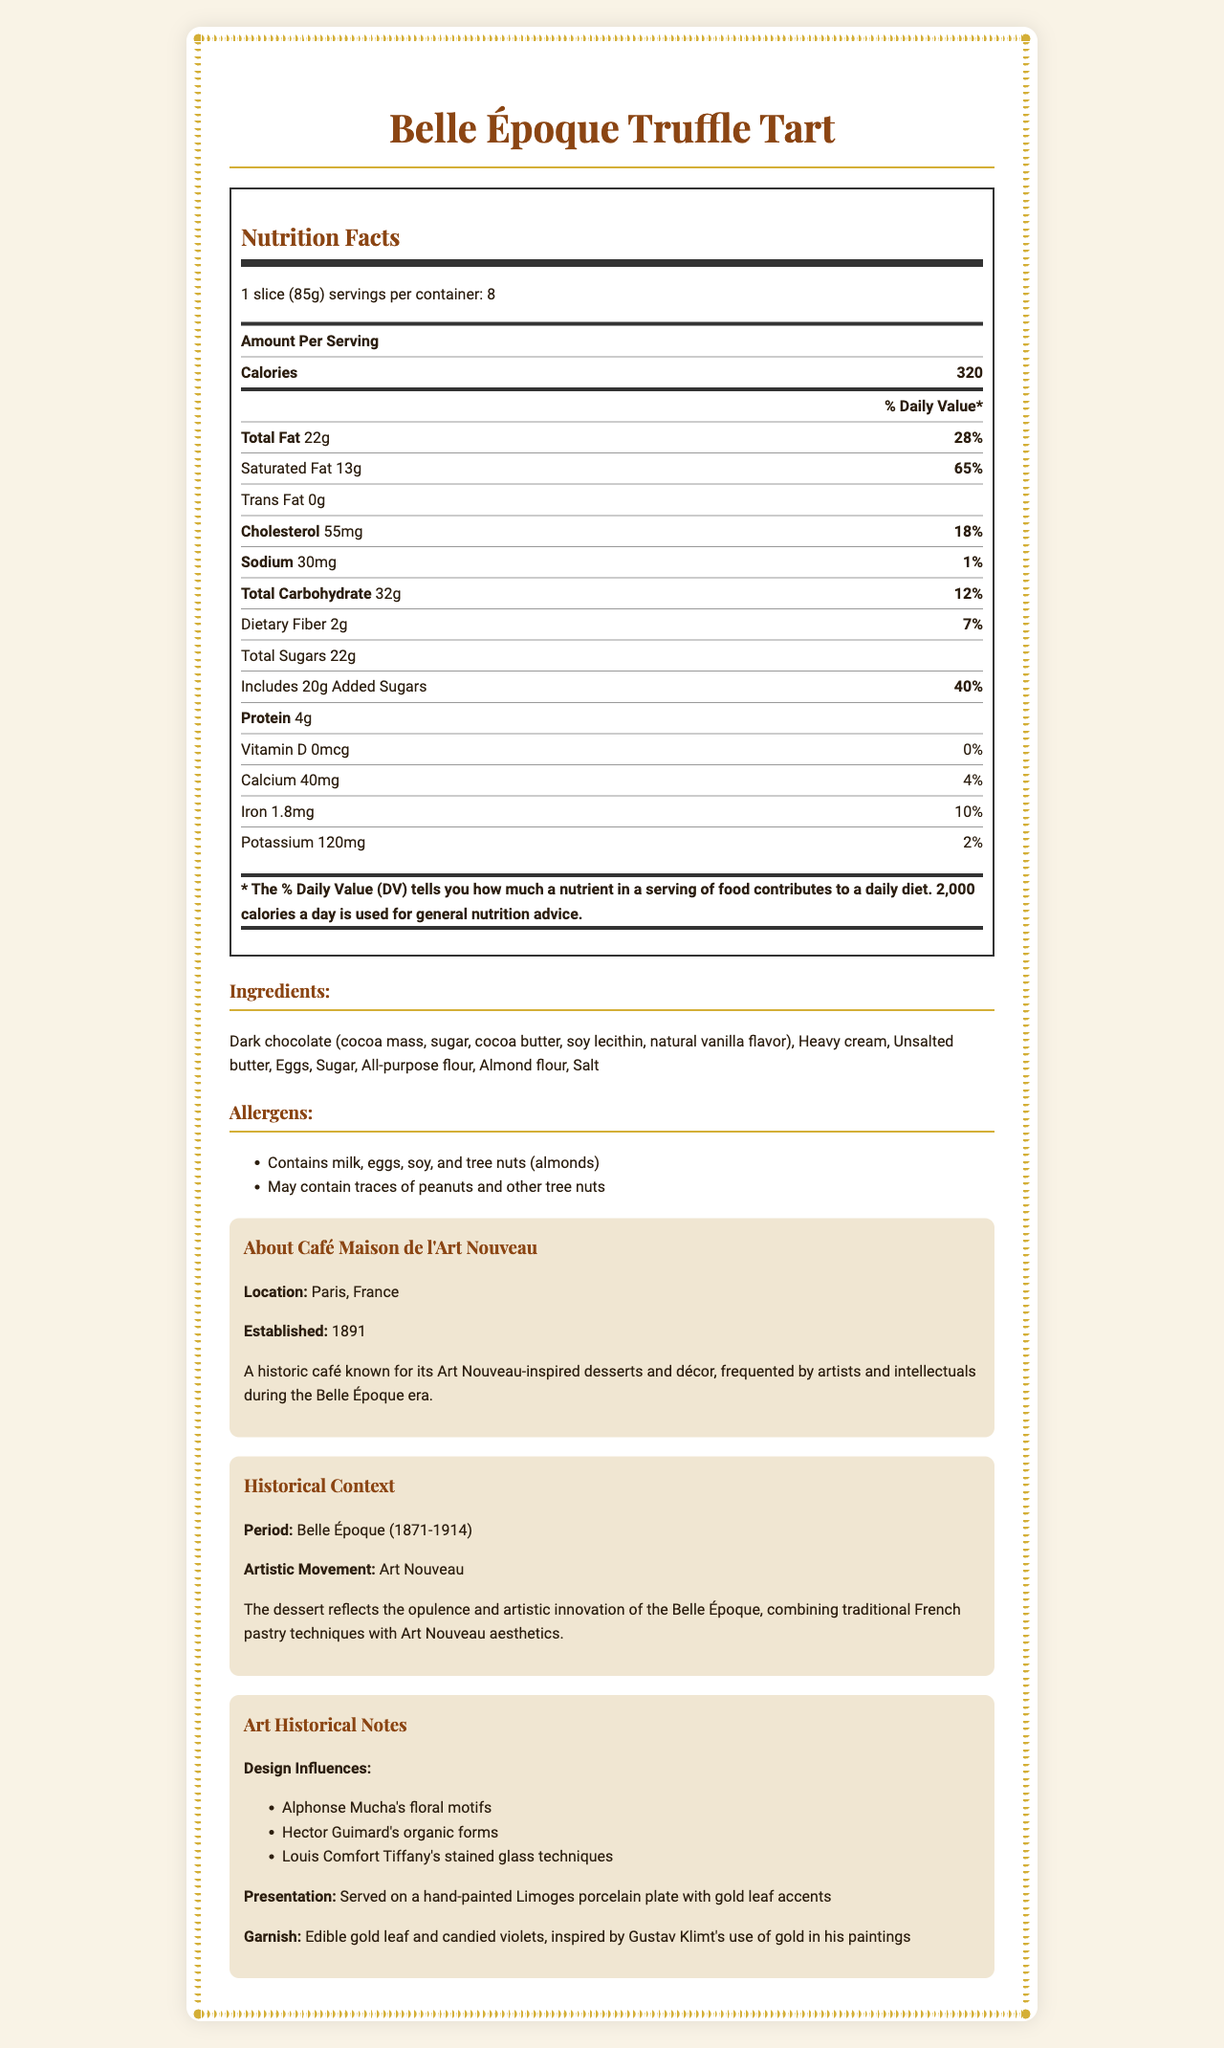who established the Café Maison de l'Art Nouveau? The document mentions the establishment year and a brief history but does not specify the founder.
Answer: Not enough information what is the serving size for the Belle Époque Truffle Tart? The document specifies that the serving size is one slice weighing 85 grams.
Answer: 1 slice (85g) how much protein is in one serving of the Belle Époque Truffle Tart? The nutrition label indicates that one serving contains 4 grams of protein.
Answer: 4 grams what allergens are present in the Belle Époque Truffle Tart? The allergens section lists milk, eggs, soy, and tree nuts (almonds) as the allergens contained in the dessert.
Answer: Milk, eggs, soy, tree nuts (almonds) How does the Belle Époque Truffle Tart's sugar content compare to its modern equivalent? The nutritional comparison section states that the dessert has lower sugar content compared to modern desserts.
Answer: Lower which ingredient in the Belle Époque Truffle Tart contains soy? The ingredients section lists dark chocolate, which includes soy lecithin as an ingredient.
Answer: Dark chocolate which artistic movement influenced the design of the Belle Époque Truffle Tart? A. Art Deco B. Art Nouveau C. Impressionism The document states that the Belle Époque Truffle Tart was influenced by the Art Nouveau movement.
Answer: B. Art Nouveau which artist's floral motifs influenced the design of the Belle Époque Truffle Tart? A. Claude Monet B. Alphonse Mucha C. Henri de Toulouse-Lautrec The art historical notes mention Alphonse Mucha's floral motifs as a design influence.
Answer: B. Alphonse Mucha does the Belle Époque Truffle Tart contain artificial preservatives? Yes/No The nutritional comparison section notes the absence of artificial preservatives in the Belle Époque Truffle Tart.
Answer: No summarize the entire document. The document includes sections on nutrition facts, ingredients, allergens, café information, historical context, and art historical notes. Each section provides specific details helping to understand the dessert's nutritional profile and cultural significance.
Answer: The document provides detailed nutrition facts and historical context for the Belle Époque Truffle Tart, a dessert from the Belle Époque era inspired by Art Nouveau. The café where it is served, Café Maison de l'Art Nouveau, is highlighted along with artistic influences on the dessert's design. The nutritional comparison to modern equivalents notes differences like higher fat content and the use of natural ingredients. what are the main ingredients of the Belle Époque Truffle Tart, excluding allergens? The ingredients section lists all the main ingredients with dark chocolate, heavy cream, unsalted butter, eggs, sugar, all-purpose flour, almond flour, and salt.
Answer: Dark chocolate, heavy cream, unsalted butter, eggs, sugar, all-purpose flour, almond flour, salt which nutrients have a percent daily value higher than 25%? The nutrition facts label lists the percent daily values for each nutrient; total fat (28%), saturated fat (65%), and added sugars (40%) are all above 25%.
Answer: Total fat, saturated fat, added sugars describe the serving presentation of the Belle Époque Truffle Tart. The art historical notes section describes the presentation and garnishing details of the tart.
Answer: The tart is served on a hand-painted Limoges porcelain plate with gold leaf accents and garnished with edible gold leaf and candied violets. what is the percent daily value of calcium in one serving? The nutrition facts label indicates that one serving of the tart provides 4% of the daily value for calcium.
Answer: 4% what is the sodium content per serving? According to the nutrition label, the sodium content per serving is 30 milligrams.
Answer: 30 mg 